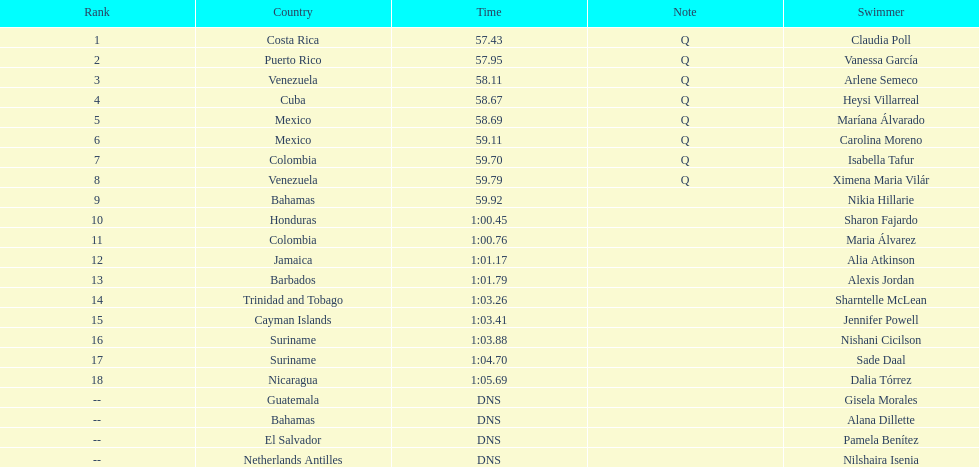Who was the only cuban to finish in the top eight? Heysi Villarreal. 